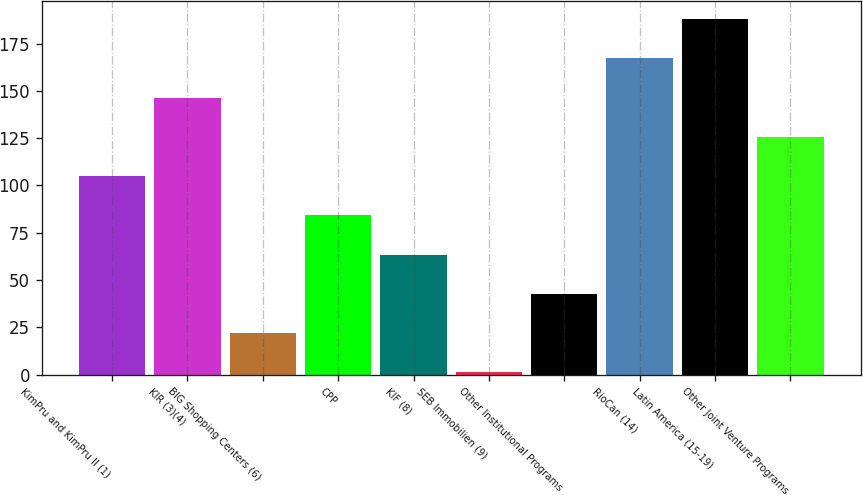Convert chart. <chart><loc_0><loc_0><loc_500><loc_500><bar_chart><fcel>KimPru and KimPru II (1)<fcel>KIR (3)(4)<fcel>BIG Shopping Centers (6)<fcel>CPP<fcel>KIF (8)<fcel>SEB Immobilien (9)<fcel>Other Institutional Programs<fcel>RioCan (14)<fcel>Latin America (15-19)<fcel>Other Joint Venture Programs<nl><fcel>104.9<fcel>146.42<fcel>21.86<fcel>84.14<fcel>63.38<fcel>1.1<fcel>42.62<fcel>167.18<fcel>187.94<fcel>125.66<nl></chart> 